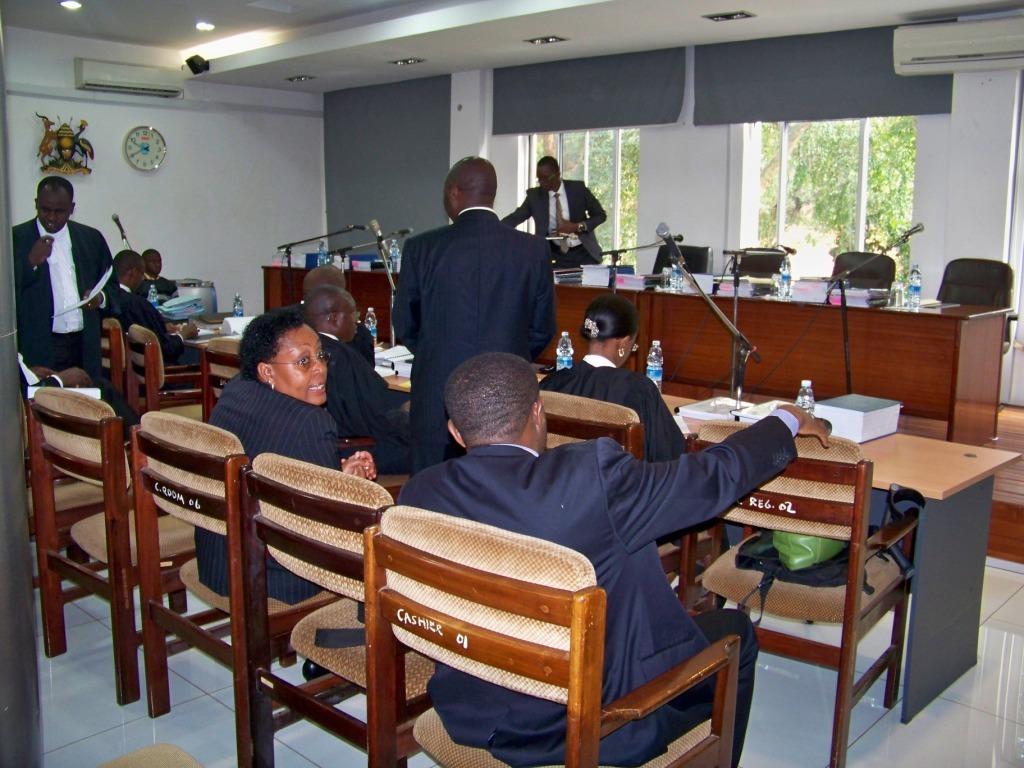Please provide a concise description of this image. In this picture we can see few persons sitting on chairs in front of a table and on the table we can see box, bottles , mike's. We can see two persons standing here. And on the platform we can see chairs and tables and on the table we can see bottles and books. We can see one man standing. This is wall and a clock, Air conditioner, ceiling and light. These are window and curtains. This is a floor. 